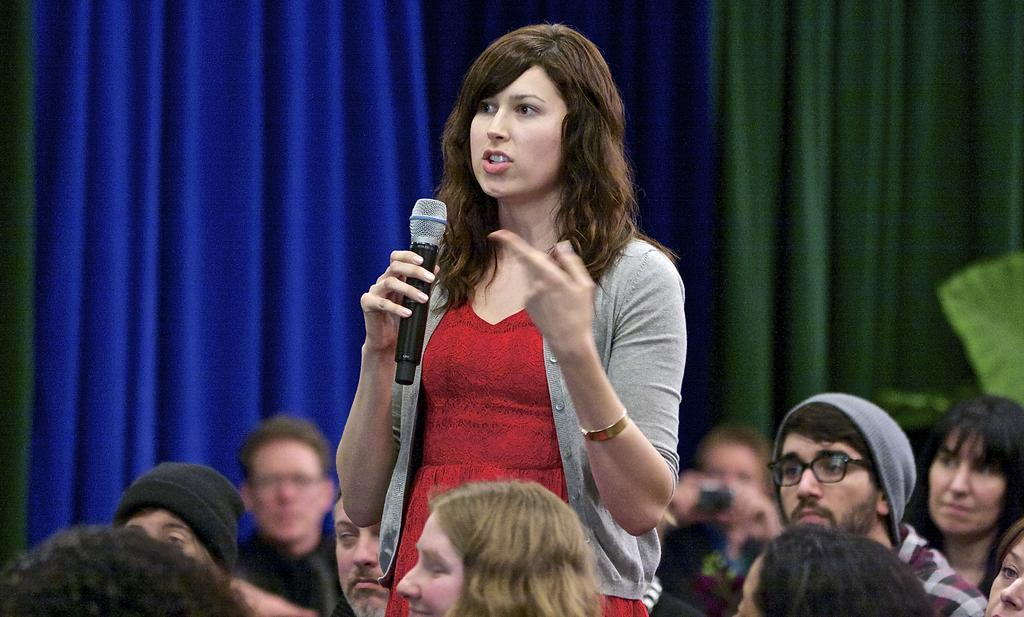What is the main subject of the image? The main subject of the image is a group of people. Can you describe the woman standing in front of the group? The woman is standing in front of the group and holding a mic. What can be seen in the background of the image? There is a curtain in the background of the image. What invention is the woman demonstrating in the image? There is no invention being demonstrated in the image; the woman is simply holding a mic. Can you tell me what type of prose the woman is reciting in the image? There is no indication in the image that the woman is reciting any prose. 